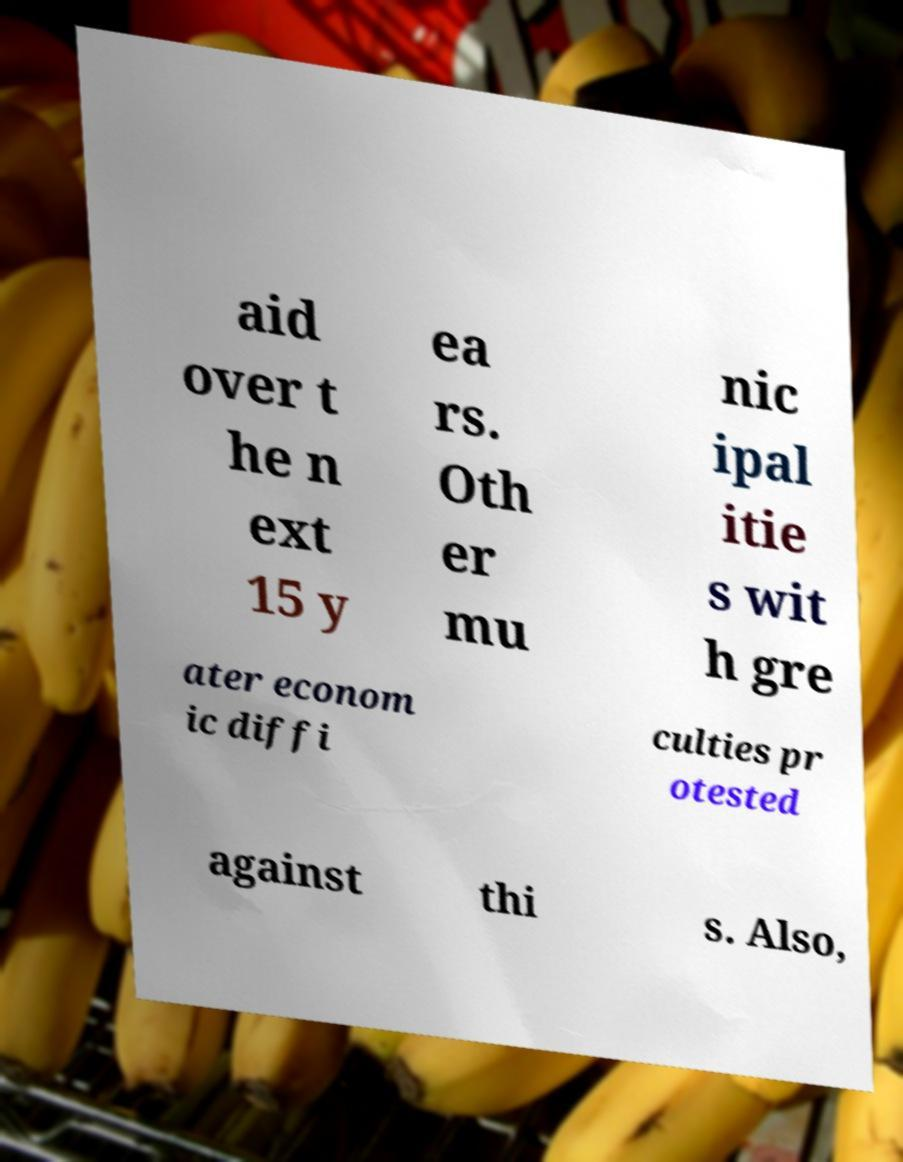I need the written content from this picture converted into text. Can you do that? aid over t he n ext 15 y ea rs. Oth er mu nic ipal itie s wit h gre ater econom ic diffi culties pr otested against thi s. Also, 